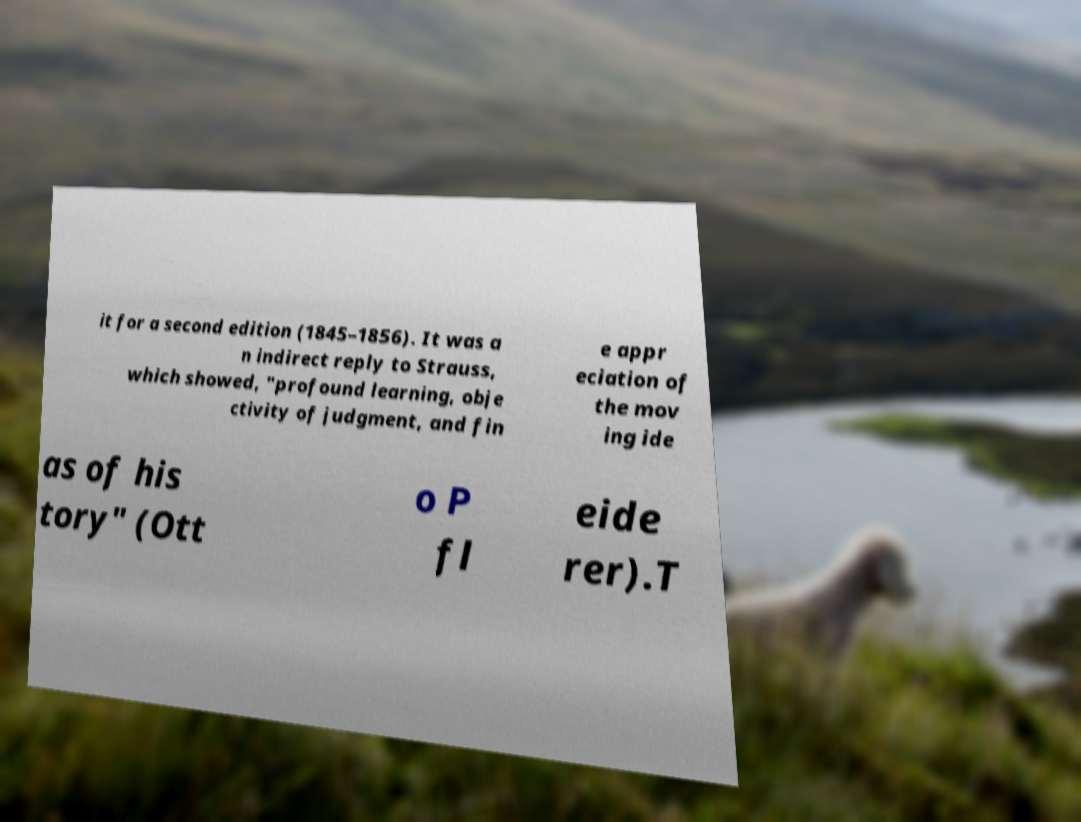Can you read and provide the text displayed in the image?This photo seems to have some interesting text. Can you extract and type it out for me? it for a second edition (1845–1856). It was a n indirect reply to Strauss, which showed, "profound learning, obje ctivity of judgment, and fin e appr eciation of the mov ing ide as of his tory" (Ott o P fl eide rer).T 